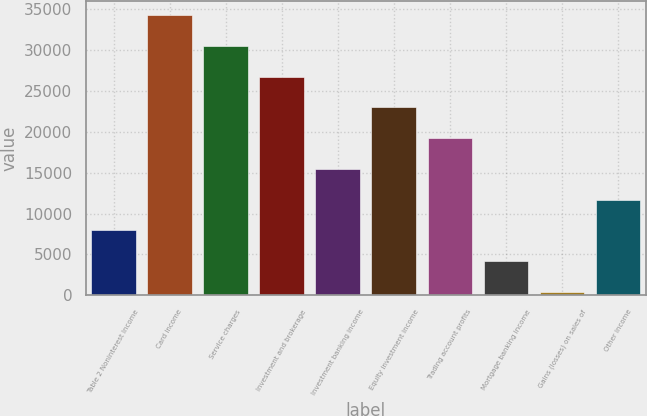Convert chart to OTSL. <chart><loc_0><loc_0><loc_500><loc_500><bar_chart><fcel>Table 2 Noninterest Income<fcel>Card income<fcel>Service charges<fcel>Investment and brokerage<fcel>Investment banking income<fcel>Equity investment income<fcel>Trading account profits<fcel>Mortgage banking income<fcel>Gains (losses) on sales of<fcel>Other income<nl><fcel>7952.2<fcel>34234.4<fcel>30479.8<fcel>26725.2<fcel>15461.4<fcel>22970.6<fcel>19216<fcel>4197.6<fcel>443<fcel>11706.8<nl></chart> 